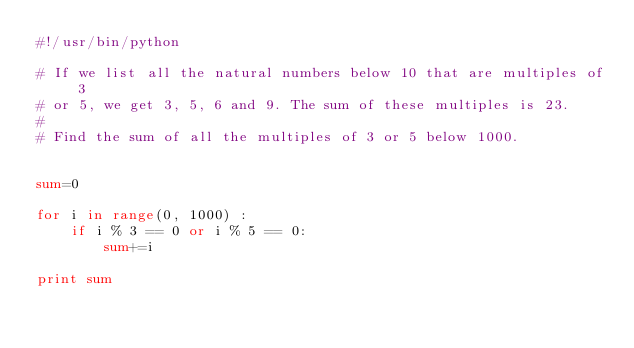Convert code to text. <code><loc_0><loc_0><loc_500><loc_500><_Python_>#!/usr/bin/python

# If we list all the natural numbers below 10 that are multiples of 3
# or 5, we get 3, 5, 6 and 9. The sum of these multiples is 23.
#
# Find the sum of all the multiples of 3 or 5 below 1000.


sum=0

for i in range(0, 1000) :
    if i % 3 == 0 or i % 5 == 0:
        sum+=i

print sum
</code> 